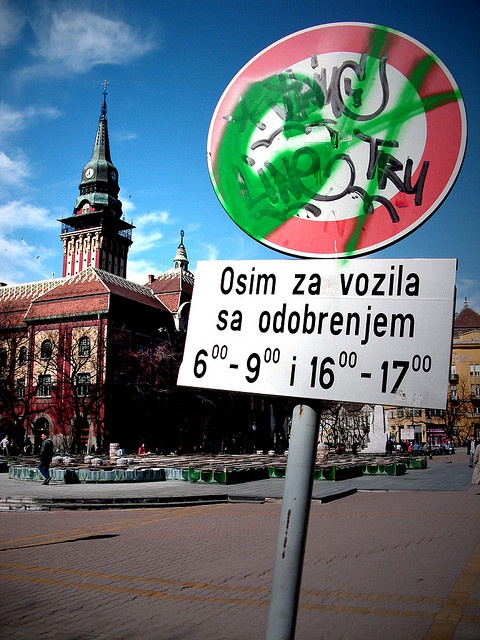Describe the objects in this image and their specific colors. I can see stop sign in gray, lightgray, green, and darkgreen tones, people in gray, black, navy, and purple tones, people in gray and black tones, people in gray, black, lavender, and maroon tones, and people in gray, black, purple, and lightpink tones in this image. 